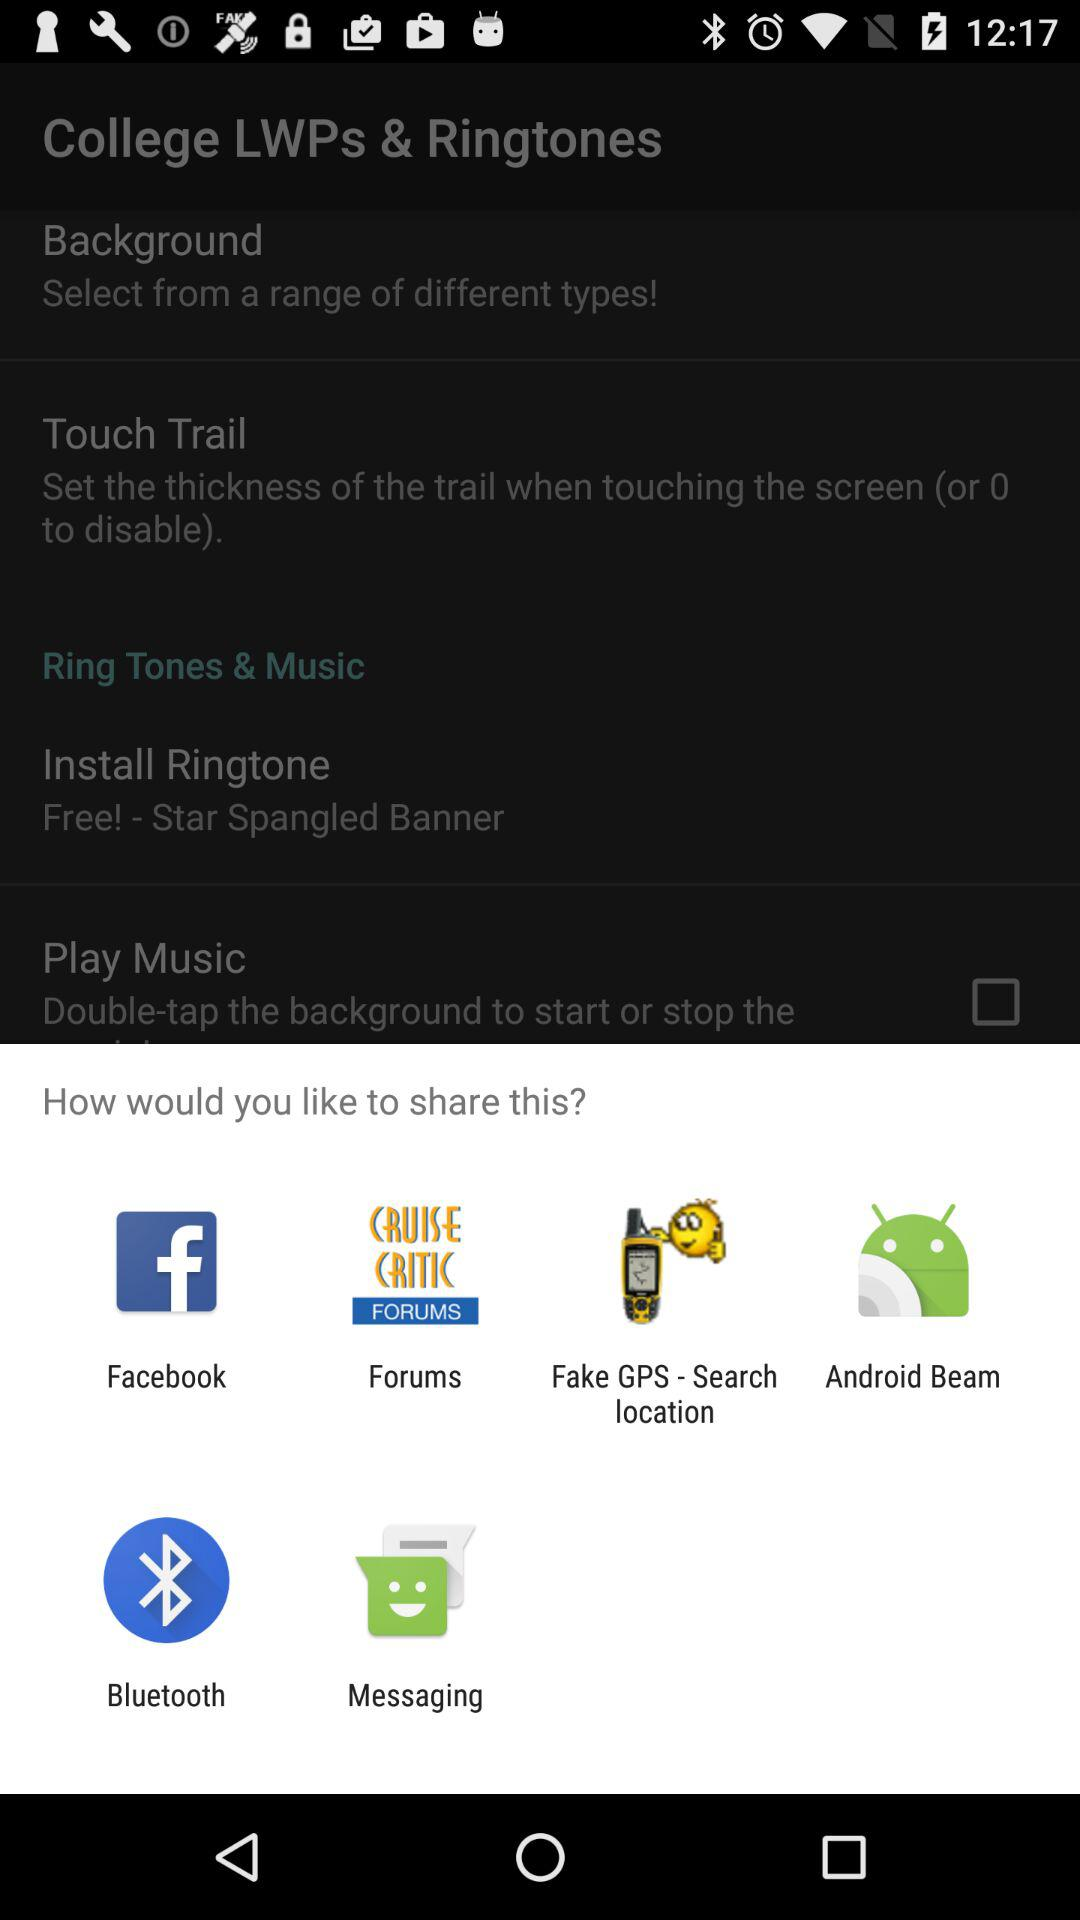What are the different sharing options? The different sharing options are "Facebook", "Forums", "Fake GPS - Search location", "Android Beam", "Bluetooth" and "Messaging". 